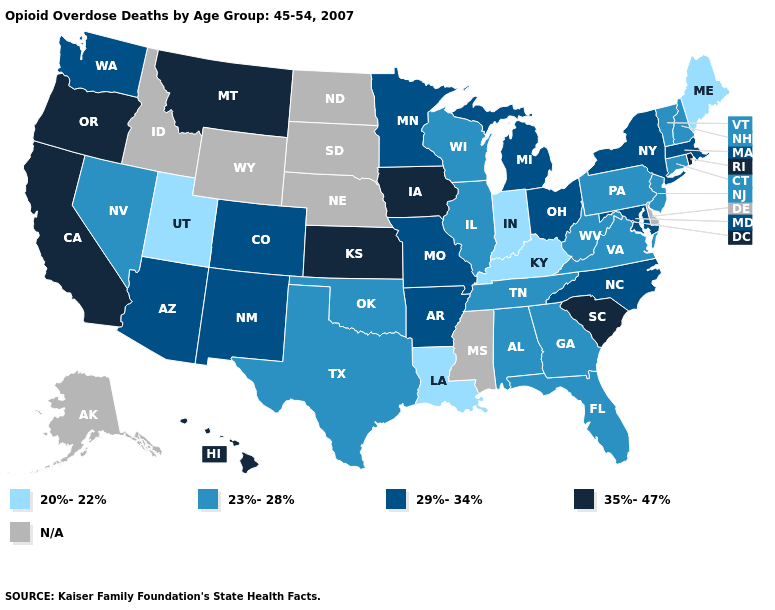Which states have the highest value in the USA?
Answer briefly. California, Hawaii, Iowa, Kansas, Montana, Oregon, Rhode Island, South Carolina. Name the states that have a value in the range 29%-34%?
Quick response, please. Arizona, Arkansas, Colorado, Maryland, Massachusetts, Michigan, Minnesota, Missouri, New Mexico, New York, North Carolina, Ohio, Washington. Name the states that have a value in the range N/A?
Short answer required. Alaska, Delaware, Idaho, Mississippi, Nebraska, North Dakota, South Dakota, Wyoming. What is the highest value in the South ?
Give a very brief answer. 35%-47%. What is the value of North Dakota?
Quick response, please. N/A. Which states have the highest value in the USA?
Be succinct. California, Hawaii, Iowa, Kansas, Montana, Oregon, Rhode Island, South Carolina. Which states have the highest value in the USA?
Quick response, please. California, Hawaii, Iowa, Kansas, Montana, Oregon, Rhode Island, South Carolina. What is the lowest value in the USA?
Write a very short answer. 20%-22%. Name the states that have a value in the range 29%-34%?
Give a very brief answer. Arizona, Arkansas, Colorado, Maryland, Massachusetts, Michigan, Minnesota, Missouri, New Mexico, New York, North Carolina, Ohio, Washington. What is the value of South Carolina?
Answer briefly. 35%-47%. Name the states that have a value in the range 35%-47%?
Short answer required. California, Hawaii, Iowa, Kansas, Montana, Oregon, Rhode Island, South Carolina. Name the states that have a value in the range 20%-22%?
Quick response, please. Indiana, Kentucky, Louisiana, Maine, Utah. Name the states that have a value in the range 23%-28%?
Concise answer only. Alabama, Connecticut, Florida, Georgia, Illinois, Nevada, New Hampshire, New Jersey, Oklahoma, Pennsylvania, Tennessee, Texas, Vermont, Virginia, West Virginia, Wisconsin. 